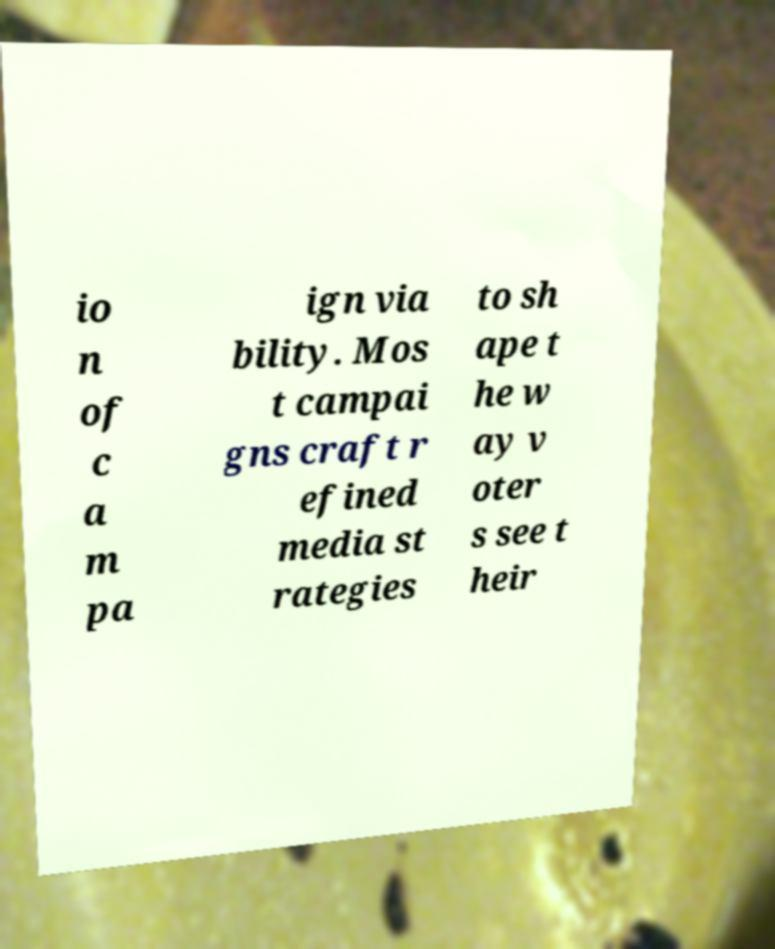There's text embedded in this image that I need extracted. Can you transcribe it verbatim? io n of c a m pa ign via bility. Mos t campai gns craft r efined media st rategies to sh ape t he w ay v oter s see t heir 